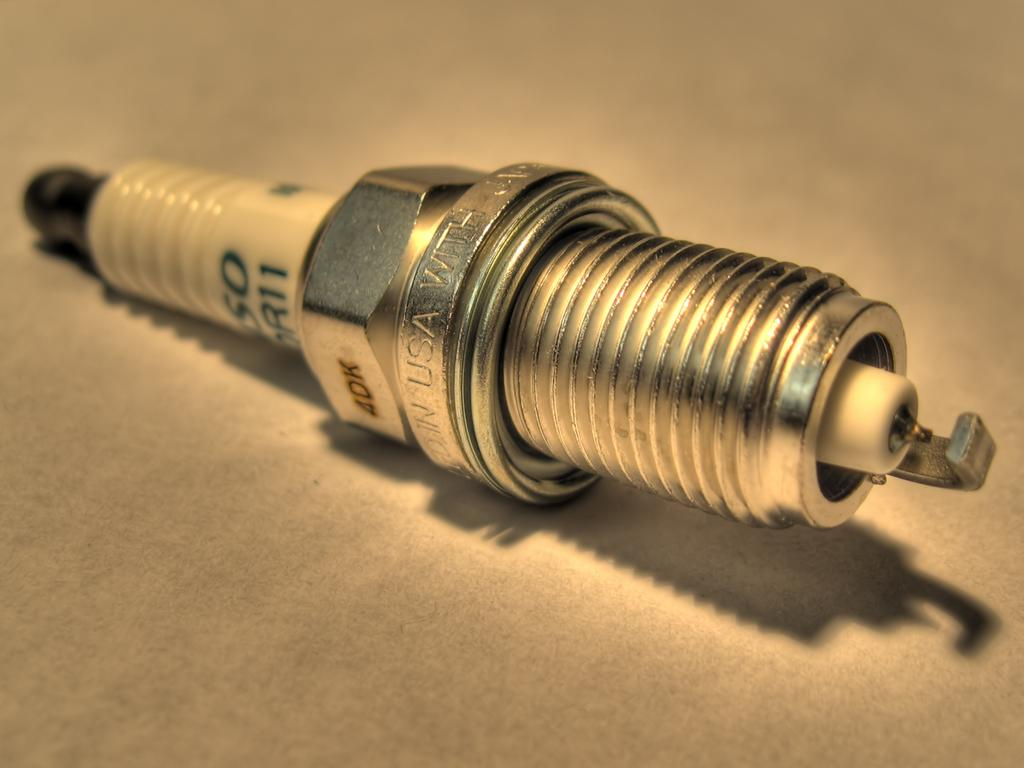What is the main object in the image? There is a spark plug in the image. Where is the spark plug located? The spark plug is kept on the floor. What type of steel is used to make the notebook in the image? There is no notebook present in the image, so it is not possible to determine the type of steel used to make it. 